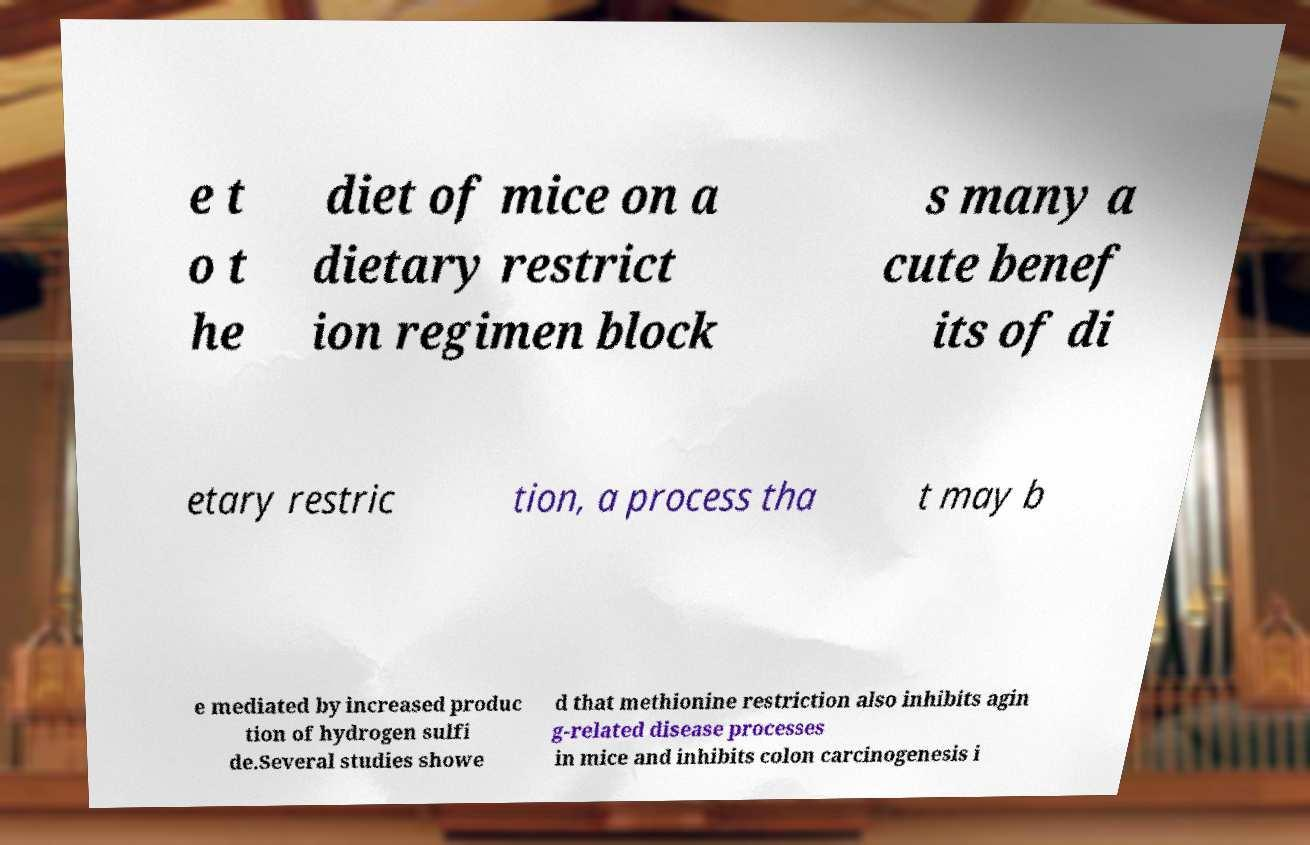What messages or text are displayed in this image? I need them in a readable, typed format. e t o t he diet of mice on a dietary restrict ion regimen block s many a cute benef its of di etary restric tion, a process tha t may b e mediated by increased produc tion of hydrogen sulfi de.Several studies showe d that methionine restriction also inhibits agin g-related disease processes in mice and inhibits colon carcinogenesis i 